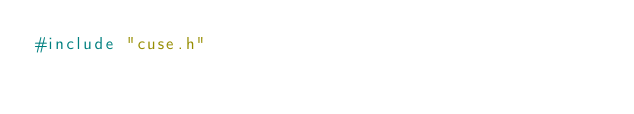Convert code to text. <code><loc_0><loc_0><loc_500><loc_500><_C_>#include "cuse.h"
</code> 